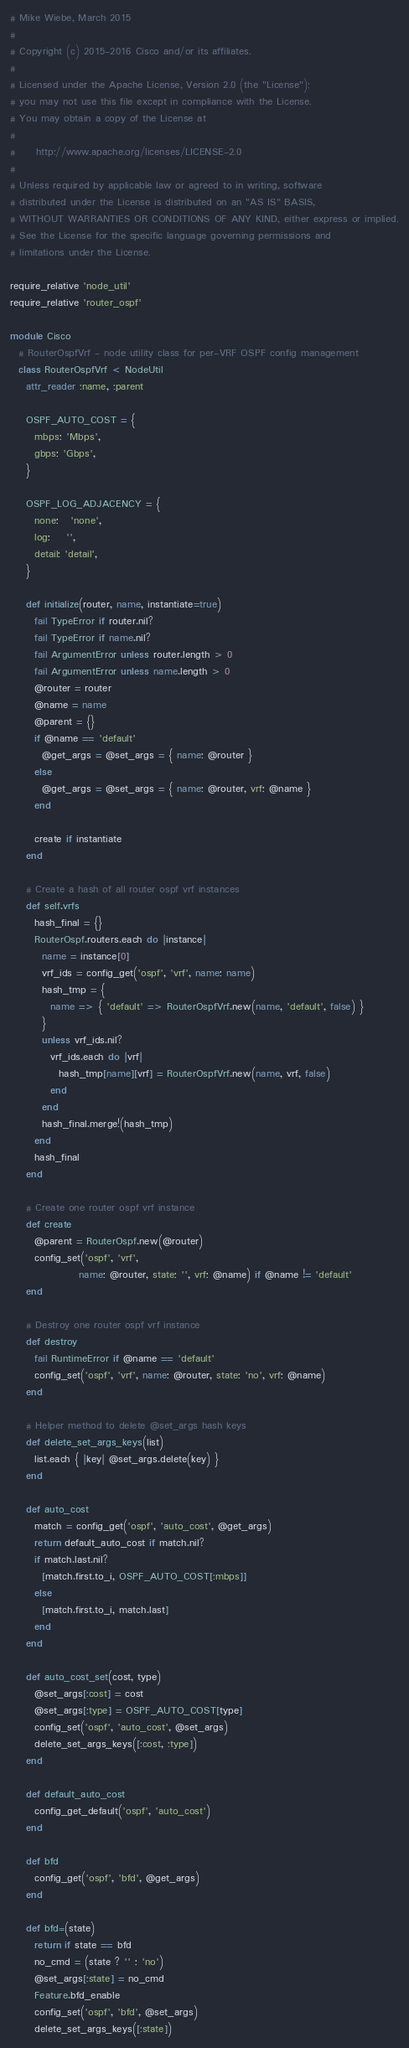<code> <loc_0><loc_0><loc_500><loc_500><_Ruby_># Mike Wiebe, March 2015
#
# Copyright (c) 2015-2016 Cisco and/or its affiliates.
#
# Licensed under the Apache License, Version 2.0 (the "License");
# you may not use this file except in compliance with the License.
# You may obtain a copy of the License at
#
#     http://www.apache.org/licenses/LICENSE-2.0
#
# Unless required by applicable law or agreed to in writing, software
# distributed under the License is distributed on an "AS IS" BASIS,
# WITHOUT WARRANTIES OR CONDITIONS OF ANY KIND, either express or implied.
# See the License for the specific language governing permissions and
# limitations under the License.

require_relative 'node_util'
require_relative 'router_ospf'

module Cisco
  # RouterOspfVrf - node utility class for per-VRF OSPF config management
  class RouterOspfVrf < NodeUtil
    attr_reader :name, :parent

    OSPF_AUTO_COST = {
      mbps: 'Mbps',
      gbps: 'Gbps',
    }

    OSPF_LOG_ADJACENCY = {
      none:   'none',
      log:    '',
      detail: 'detail',
    }

    def initialize(router, name, instantiate=true)
      fail TypeError if router.nil?
      fail TypeError if name.nil?
      fail ArgumentError unless router.length > 0
      fail ArgumentError unless name.length > 0
      @router = router
      @name = name
      @parent = {}
      if @name == 'default'
        @get_args = @set_args = { name: @router }
      else
        @get_args = @set_args = { name: @router, vrf: @name }
      end

      create if instantiate
    end

    # Create a hash of all router ospf vrf instances
    def self.vrfs
      hash_final = {}
      RouterOspf.routers.each do |instance|
        name = instance[0]
        vrf_ids = config_get('ospf', 'vrf', name: name)
        hash_tmp = {
          name => { 'default' => RouterOspfVrf.new(name, 'default', false) }
        }
        unless vrf_ids.nil?
          vrf_ids.each do |vrf|
            hash_tmp[name][vrf] = RouterOspfVrf.new(name, vrf, false)
          end
        end
        hash_final.merge!(hash_tmp)
      end
      hash_final
    end

    # Create one router ospf vrf instance
    def create
      @parent = RouterOspf.new(@router)
      config_set('ospf', 'vrf',
                 name: @router, state: '', vrf: @name) if @name != 'default'
    end

    # Destroy one router ospf vrf instance
    def destroy
      fail RuntimeError if @name == 'default'
      config_set('ospf', 'vrf', name: @router, state: 'no', vrf: @name)
    end

    # Helper method to delete @set_args hash keys
    def delete_set_args_keys(list)
      list.each { |key| @set_args.delete(key) }
    end

    def auto_cost
      match = config_get('ospf', 'auto_cost', @get_args)
      return default_auto_cost if match.nil?
      if match.last.nil?
        [match.first.to_i, OSPF_AUTO_COST[:mbps]]
      else
        [match.first.to_i, match.last]
      end
    end

    def auto_cost_set(cost, type)
      @set_args[:cost] = cost
      @set_args[:type] = OSPF_AUTO_COST[type]
      config_set('ospf', 'auto_cost', @set_args)
      delete_set_args_keys([:cost, :type])
    end

    def default_auto_cost
      config_get_default('ospf', 'auto_cost')
    end

    def bfd
      config_get('ospf', 'bfd', @get_args)
    end

    def bfd=(state)
      return if state == bfd
      no_cmd = (state ? '' : 'no')
      @set_args[:state] = no_cmd
      Feature.bfd_enable
      config_set('ospf', 'bfd', @set_args)
      delete_set_args_keys([:state])</code> 